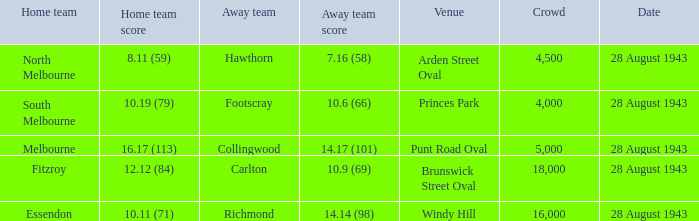Where was the game played with an away team score of 14.17 (101)? Punt Road Oval. 